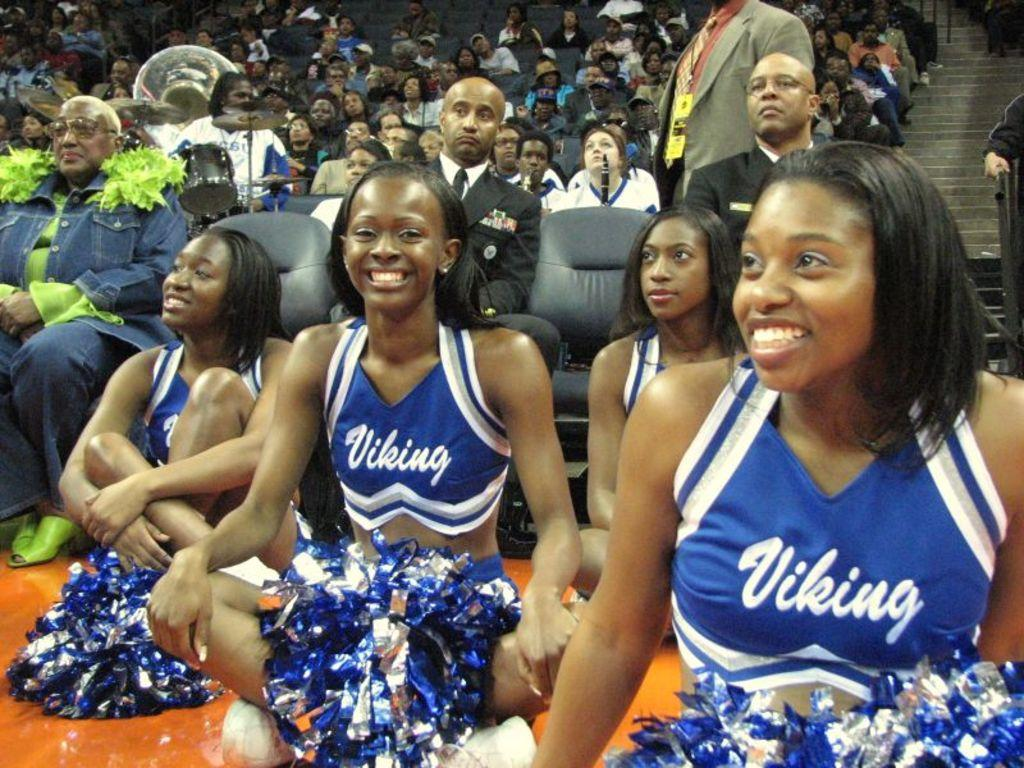<image>
Offer a succinct explanation of the picture presented. A group of Vinking cheerleaders sitting on the floor. 